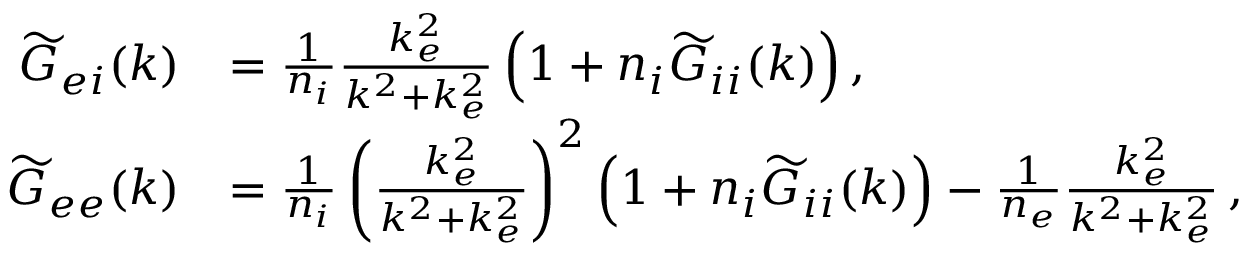Convert formula to latex. <formula><loc_0><loc_0><loc_500><loc_500>\begin{array} { r l } { \widetilde { G } _ { e i } ( k ) } & { = \frac { 1 } { n _ { i } } \frac { k _ { e } ^ { 2 } } { k ^ { 2 } + k _ { e } ^ { 2 } } \left ( 1 + n _ { i } \widetilde { G } _ { i i } ( k ) \right ) , } \\ { \widetilde { G } _ { e e } ( k ) } & { = \frac { 1 } { n _ { i } } \left ( \frac { k _ { e } ^ { 2 } } { k ^ { 2 } + k _ { e } ^ { 2 } } \right ) ^ { 2 } \left ( 1 + n _ { i } \widetilde { G } _ { i i } ( k ) \right ) - \frac { 1 } { n _ { e } } \frac { k _ { e } ^ { 2 } } { k ^ { 2 } + k _ { e } ^ { 2 } } \, , } \end{array}</formula> 